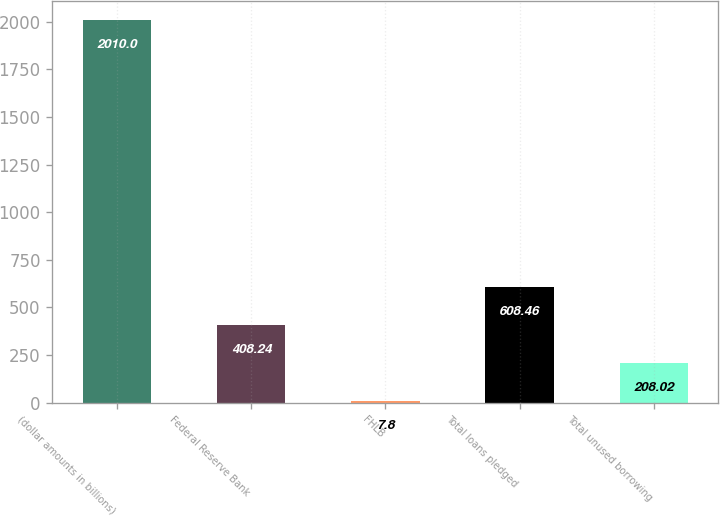<chart> <loc_0><loc_0><loc_500><loc_500><bar_chart><fcel>(dollar amounts in billions)<fcel>Federal Reserve Bank<fcel>FHLB<fcel>Total loans pledged<fcel>Total unused borrowing<nl><fcel>2010<fcel>408.24<fcel>7.8<fcel>608.46<fcel>208.02<nl></chart> 